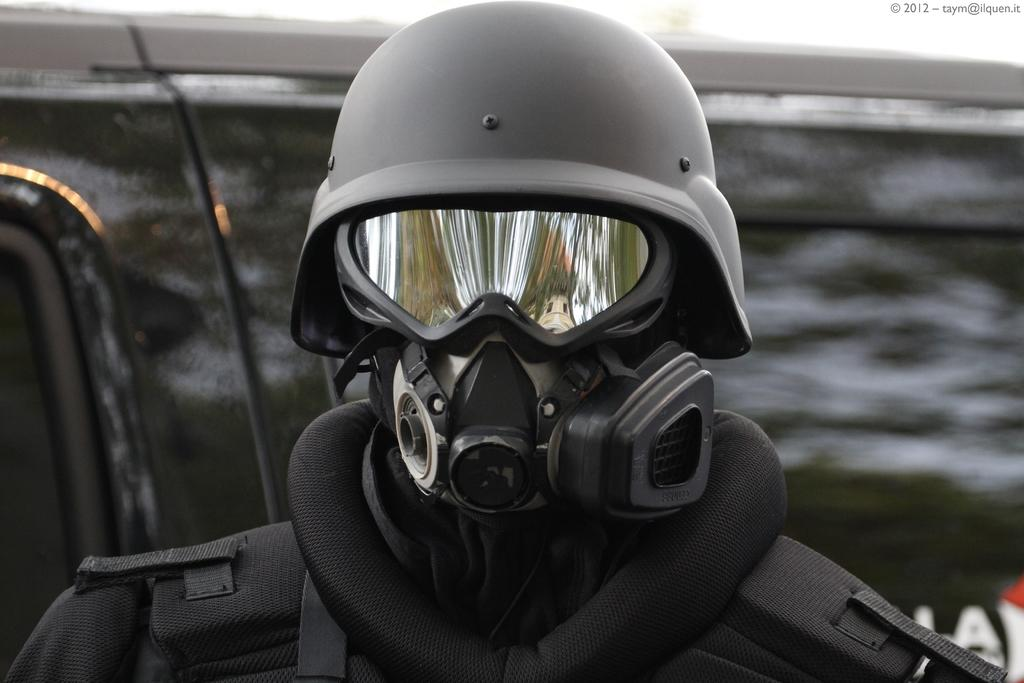Who or what is the main subject in the image? There is a person in the image. What protective gear is the person wearing? The person is wearing a helmet and a face mask. Can you describe the background of the image? The background of the image is blurry. What time is displayed on the clock in the image? There is no clock present in the image. What type of answer is the person providing in the image? The image does not show the person providing an answer, as it only shows the person wearing a helmet and a face mask. 